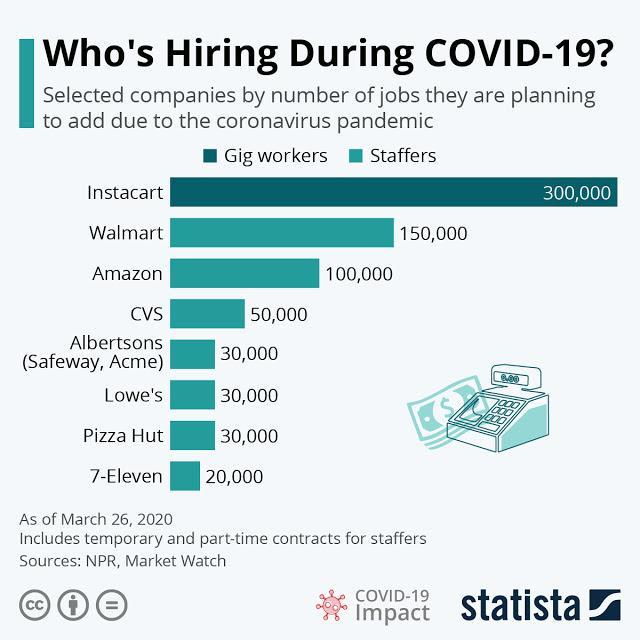How many new jobs were planned to be added by the Amazon due to the Coronavirus pandemic as of March 26, 2020?
Answer the question with a short phrase. 100,000 Which company has planned to add least number of jobs among the selected companies due to the Coronavirus pandemic as of March 26, 2020? 7-Eleven How many new jobs were planned to be added by the Walmart due to the Coronavirus pandemic as of March 26, 2020? 150,000 Which company has planned to add the highest number of jobs among the selected companies due to the Coronavirus pandemic as of March 26, 2020? Instacart Which company has planned the second highest number of jobs to be added among the selected companies due to the Coronavirus pandemic as of March 26, 2020? Walmart 